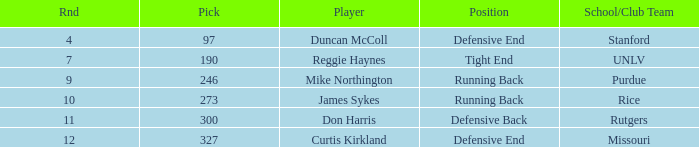Can you parse all the data within this table? {'header': ['Rnd', 'Pick', 'Player', 'Position', 'School/Club Team'], 'rows': [['4', '97', 'Duncan McColl', 'Defensive End', 'Stanford'], ['7', '190', 'Reggie Haynes', 'Tight End', 'UNLV'], ['9', '246', 'Mike Northington', 'Running Back', 'Purdue'], ['10', '273', 'James Sykes', 'Running Back', 'Rice'], ['11', '300', 'Don Harris', 'Defensive Back', 'Rutgers'], ['12', '327', 'Curtis Kirkland', 'Defensive End', 'Missouri']]} What is the highest round number for the player who came from team Missouri? 12.0. 